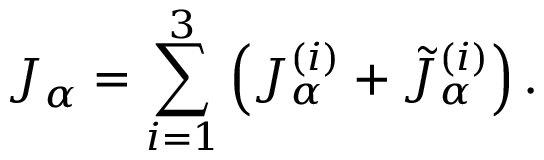<formula> <loc_0><loc_0><loc_500><loc_500>J _ { \alpha } = \sum _ { i = 1 } ^ { 3 } \left ( J _ { \alpha } ^ { ( i ) } + \tilde { J } _ { \alpha } ^ { ( i ) } \right ) .</formula> 